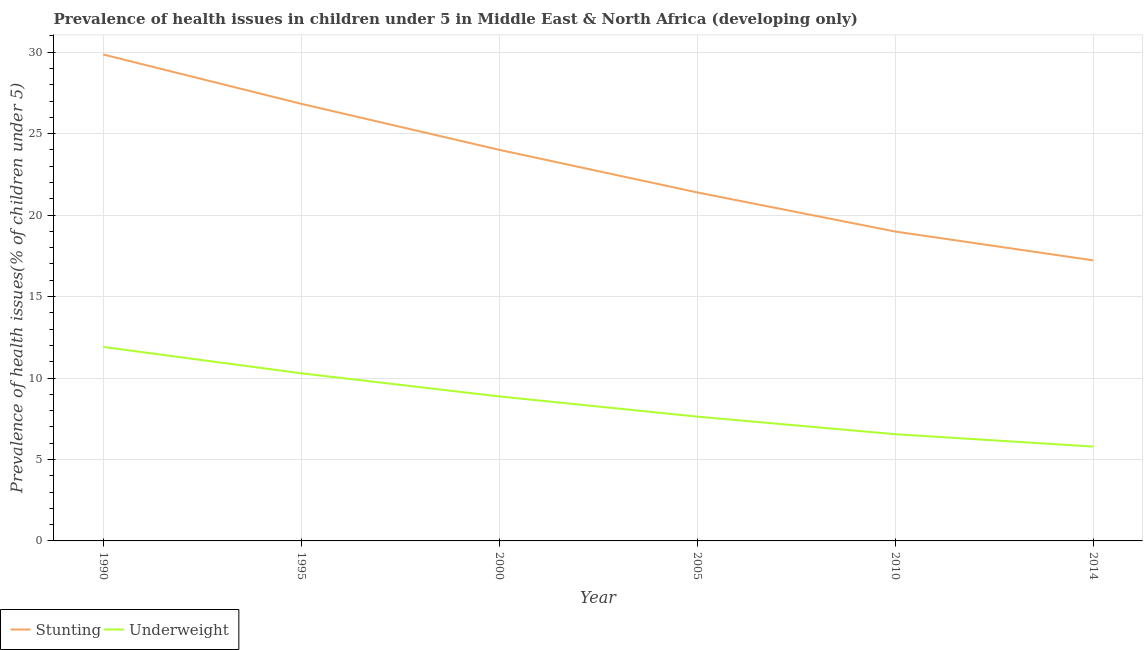How many different coloured lines are there?
Provide a short and direct response. 2. Does the line corresponding to percentage of stunted children intersect with the line corresponding to percentage of underweight children?
Your response must be concise. No. What is the percentage of underweight children in 2000?
Your answer should be compact. 8.87. Across all years, what is the maximum percentage of stunted children?
Offer a very short reply. 29.86. Across all years, what is the minimum percentage of underweight children?
Offer a terse response. 5.79. In which year was the percentage of underweight children minimum?
Keep it short and to the point. 2014. What is the total percentage of underweight children in the graph?
Provide a succinct answer. 51.04. What is the difference between the percentage of stunted children in 1990 and that in 2000?
Your answer should be compact. 5.85. What is the difference between the percentage of underweight children in 1990 and the percentage of stunted children in 2014?
Your answer should be very brief. -5.32. What is the average percentage of stunted children per year?
Your response must be concise. 23.05. In the year 2005, what is the difference between the percentage of underweight children and percentage of stunted children?
Offer a terse response. -13.76. What is the ratio of the percentage of underweight children in 1995 to that in 2000?
Your answer should be very brief. 1.16. What is the difference between the highest and the second highest percentage of underweight children?
Provide a succinct answer. 1.62. What is the difference between the highest and the lowest percentage of stunted children?
Your answer should be compact. 12.64. Is the percentage of stunted children strictly less than the percentage of underweight children over the years?
Make the answer very short. No. How many lines are there?
Ensure brevity in your answer.  2. How many years are there in the graph?
Provide a short and direct response. 6. Are the values on the major ticks of Y-axis written in scientific E-notation?
Your response must be concise. No. Does the graph contain any zero values?
Keep it short and to the point. No. How many legend labels are there?
Make the answer very short. 2. How are the legend labels stacked?
Offer a terse response. Horizontal. What is the title of the graph?
Provide a short and direct response. Prevalence of health issues in children under 5 in Middle East & North Africa (developing only). Does "Manufacturing industries and construction" appear as one of the legend labels in the graph?
Offer a very short reply. No. What is the label or title of the X-axis?
Make the answer very short. Year. What is the label or title of the Y-axis?
Make the answer very short. Prevalence of health issues(% of children under 5). What is the Prevalence of health issues(% of children under 5) in Stunting in 1990?
Your answer should be very brief. 29.86. What is the Prevalence of health issues(% of children under 5) in Underweight in 1990?
Keep it short and to the point. 11.91. What is the Prevalence of health issues(% of children under 5) in Stunting in 1995?
Ensure brevity in your answer.  26.83. What is the Prevalence of health issues(% of children under 5) in Underweight in 1995?
Keep it short and to the point. 10.29. What is the Prevalence of health issues(% of children under 5) in Stunting in 2000?
Keep it short and to the point. 24.01. What is the Prevalence of health issues(% of children under 5) in Underweight in 2000?
Your response must be concise. 8.87. What is the Prevalence of health issues(% of children under 5) of Stunting in 2005?
Offer a very short reply. 21.39. What is the Prevalence of health issues(% of children under 5) of Underweight in 2005?
Your response must be concise. 7.63. What is the Prevalence of health issues(% of children under 5) in Stunting in 2010?
Your answer should be very brief. 18.99. What is the Prevalence of health issues(% of children under 5) of Underweight in 2010?
Your answer should be compact. 6.55. What is the Prevalence of health issues(% of children under 5) of Stunting in 2014?
Provide a short and direct response. 17.23. What is the Prevalence of health issues(% of children under 5) of Underweight in 2014?
Ensure brevity in your answer.  5.79. Across all years, what is the maximum Prevalence of health issues(% of children under 5) in Stunting?
Your response must be concise. 29.86. Across all years, what is the maximum Prevalence of health issues(% of children under 5) in Underweight?
Your answer should be compact. 11.91. Across all years, what is the minimum Prevalence of health issues(% of children under 5) in Stunting?
Offer a terse response. 17.23. Across all years, what is the minimum Prevalence of health issues(% of children under 5) of Underweight?
Keep it short and to the point. 5.79. What is the total Prevalence of health issues(% of children under 5) of Stunting in the graph?
Your answer should be very brief. 138.32. What is the total Prevalence of health issues(% of children under 5) in Underweight in the graph?
Provide a succinct answer. 51.04. What is the difference between the Prevalence of health issues(% of children under 5) of Stunting in 1990 and that in 1995?
Make the answer very short. 3.03. What is the difference between the Prevalence of health issues(% of children under 5) of Underweight in 1990 and that in 1995?
Your answer should be compact. 1.62. What is the difference between the Prevalence of health issues(% of children under 5) in Stunting in 1990 and that in 2000?
Ensure brevity in your answer.  5.85. What is the difference between the Prevalence of health issues(% of children under 5) in Underweight in 1990 and that in 2000?
Your response must be concise. 3.04. What is the difference between the Prevalence of health issues(% of children under 5) of Stunting in 1990 and that in 2005?
Provide a succinct answer. 8.47. What is the difference between the Prevalence of health issues(% of children under 5) of Underweight in 1990 and that in 2005?
Provide a short and direct response. 4.28. What is the difference between the Prevalence of health issues(% of children under 5) in Stunting in 1990 and that in 2010?
Ensure brevity in your answer.  10.87. What is the difference between the Prevalence of health issues(% of children under 5) of Underweight in 1990 and that in 2010?
Your response must be concise. 5.36. What is the difference between the Prevalence of health issues(% of children under 5) of Stunting in 1990 and that in 2014?
Make the answer very short. 12.64. What is the difference between the Prevalence of health issues(% of children under 5) of Underweight in 1990 and that in 2014?
Give a very brief answer. 6.12. What is the difference between the Prevalence of health issues(% of children under 5) of Stunting in 1995 and that in 2000?
Your response must be concise. 2.83. What is the difference between the Prevalence of health issues(% of children under 5) in Underweight in 1995 and that in 2000?
Provide a short and direct response. 1.42. What is the difference between the Prevalence of health issues(% of children under 5) of Stunting in 1995 and that in 2005?
Your answer should be compact. 5.44. What is the difference between the Prevalence of health issues(% of children under 5) of Underweight in 1995 and that in 2005?
Keep it short and to the point. 2.66. What is the difference between the Prevalence of health issues(% of children under 5) in Stunting in 1995 and that in 2010?
Offer a terse response. 7.84. What is the difference between the Prevalence of health issues(% of children under 5) in Underweight in 1995 and that in 2010?
Offer a terse response. 3.74. What is the difference between the Prevalence of health issues(% of children under 5) of Stunting in 1995 and that in 2014?
Give a very brief answer. 9.61. What is the difference between the Prevalence of health issues(% of children under 5) in Underweight in 1995 and that in 2014?
Offer a very short reply. 4.5. What is the difference between the Prevalence of health issues(% of children under 5) in Stunting in 2000 and that in 2005?
Give a very brief answer. 2.61. What is the difference between the Prevalence of health issues(% of children under 5) of Underweight in 2000 and that in 2005?
Ensure brevity in your answer.  1.24. What is the difference between the Prevalence of health issues(% of children under 5) in Stunting in 2000 and that in 2010?
Provide a succinct answer. 5.02. What is the difference between the Prevalence of health issues(% of children under 5) in Underweight in 2000 and that in 2010?
Make the answer very short. 2.32. What is the difference between the Prevalence of health issues(% of children under 5) of Stunting in 2000 and that in 2014?
Provide a short and direct response. 6.78. What is the difference between the Prevalence of health issues(% of children under 5) of Underweight in 2000 and that in 2014?
Provide a short and direct response. 3.08. What is the difference between the Prevalence of health issues(% of children under 5) in Stunting in 2005 and that in 2010?
Provide a succinct answer. 2.4. What is the difference between the Prevalence of health issues(% of children under 5) in Underweight in 2005 and that in 2010?
Give a very brief answer. 1.08. What is the difference between the Prevalence of health issues(% of children under 5) of Stunting in 2005 and that in 2014?
Ensure brevity in your answer.  4.17. What is the difference between the Prevalence of health issues(% of children under 5) in Underweight in 2005 and that in 2014?
Give a very brief answer. 1.84. What is the difference between the Prevalence of health issues(% of children under 5) of Stunting in 2010 and that in 2014?
Offer a terse response. 1.77. What is the difference between the Prevalence of health issues(% of children under 5) of Underweight in 2010 and that in 2014?
Your answer should be very brief. 0.76. What is the difference between the Prevalence of health issues(% of children under 5) of Stunting in 1990 and the Prevalence of health issues(% of children under 5) of Underweight in 1995?
Make the answer very short. 19.57. What is the difference between the Prevalence of health issues(% of children under 5) of Stunting in 1990 and the Prevalence of health issues(% of children under 5) of Underweight in 2000?
Offer a terse response. 20.99. What is the difference between the Prevalence of health issues(% of children under 5) in Stunting in 1990 and the Prevalence of health issues(% of children under 5) in Underweight in 2005?
Make the answer very short. 22.23. What is the difference between the Prevalence of health issues(% of children under 5) in Stunting in 1990 and the Prevalence of health issues(% of children under 5) in Underweight in 2010?
Provide a short and direct response. 23.31. What is the difference between the Prevalence of health issues(% of children under 5) of Stunting in 1990 and the Prevalence of health issues(% of children under 5) of Underweight in 2014?
Your response must be concise. 24.07. What is the difference between the Prevalence of health issues(% of children under 5) of Stunting in 1995 and the Prevalence of health issues(% of children under 5) of Underweight in 2000?
Ensure brevity in your answer.  17.96. What is the difference between the Prevalence of health issues(% of children under 5) of Stunting in 1995 and the Prevalence of health issues(% of children under 5) of Underweight in 2005?
Offer a terse response. 19.2. What is the difference between the Prevalence of health issues(% of children under 5) of Stunting in 1995 and the Prevalence of health issues(% of children under 5) of Underweight in 2010?
Provide a succinct answer. 20.28. What is the difference between the Prevalence of health issues(% of children under 5) of Stunting in 1995 and the Prevalence of health issues(% of children under 5) of Underweight in 2014?
Ensure brevity in your answer.  21.04. What is the difference between the Prevalence of health issues(% of children under 5) of Stunting in 2000 and the Prevalence of health issues(% of children under 5) of Underweight in 2005?
Keep it short and to the point. 16.38. What is the difference between the Prevalence of health issues(% of children under 5) in Stunting in 2000 and the Prevalence of health issues(% of children under 5) in Underweight in 2010?
Give a very brief answer. 17.46. What is the difference between the Prevalence of health issues(% of children under 5) in Stunting in 2000 and the Prevalence of health issues(% of children under 5) in Underweight in 2014?
Make the answer very short. 18.22. What is the difference between the Prevalence of health issues(% of children under 5) of Stunting in 2005 and the Prevalence of health issues(% of children under 5) of Underweight in 2010?
Your answer should be very brief. 14.84. What is the difference between the Prevalence of health issues(% of children under 5) in Stunting in 2005 and the Prevalence of health issues(% of children under 5) in Underweight in 2014?
Give a very brief answer. 15.6. What is the difference between the Prevalence of health issues(% of children under 5) of Stunting in 2010 and the Prevalence of health issues(% of children under 5) of Underweight in 2014?
Give a very brief answer. 13.2. What is the average Prevalence of health issues(% of children under 5) in Stunting per year?
Offer a very short reply. 23.05. What is the average Prevalence of health issues(% of children under 5) in Underweight per year?
Your response must be concise. 8.51. In the year 1990, what is the difference between the Prevalence of health issues(% of children under 5) in Stunting and Prevalence of health issues(% of children under 5) in Underweight?
Offer a very short reply. 17.95. In the year 1995, what is the difference between the Prevalence of health issues(% of children under 5) of Stunting and Prevalence of health issues(% of children under 5) of Underweight?
Your answer should be very brief. 16.54. In the year 2000, what is the difference between the Prevalence of health issues(% of children under 5) of Stunting and Prevalence of health issues(% of children under 5) of Underweight?
Ensure brevity in your answer.  15.14. In the year 2005, what is the difference between the Prevalence of health issues(% of children under 5) of Stunting and Prevalence of health issues(% of children under 5) of Underweight?
Your answer should be very brief. 13.76. In the year 2010, what is the difference between the Prevalence of health issues(% of children under 5) of Stunting and Prevalence of health issues(% of children under 5) of Underweight?
Your answer should be compact. 12.44. In the year 2014, what is the difference between the Prevalence of health issues(% of children under 5) of Stunting and Prevalence of health issues(% of children under 5) of Underweight?
Offer a terse response. 11.43. What is the ratio of the Prevalence of health issues(% of children under 5) in Stunting in 1990 to that in 1995?
Keep it short and to the point. 1.11. What is the ratio of the Prevalence of health issues(% of children under 5) of Underweight in 1990 to that in 1995?
Make the answer very short. 1.16. What is the ratio of the Prevalence of health issues(% of children under 5) in Stunting in 1990 to that in 2000?
Offer a very short reply. 1.24. What is the ratio of the Prevalence of health issues(% of children under 5) of Underweight in 1990 to that in 2000?
Your answer should be very brief. 1.34. What is the ratio of the Prevalence of health issues(% of children under 5) of Stunting in 1990 to that in 2005?
Keep it short and to the point. 1.4. What is the ratio of the Prevalence of health issues(% of children under 5) in Underweight in 1990 to that in 2005?
Offer a very short reply. 1.56. What is the ratio of the Prevalence of health issues(% of children under 5) of Stunting in 1990 to that in 2010?
Provide a short and direct response. 1.57. What is the ratio of the Prevalence of health issues(% of children under 5) in Underweight in 1990 to that in 2010?
Give a very brief answer. 1.82. What is the ratio of the Prevalence of health issues(% of children under 5) in Stunting in 1990 to that in 2014?
Offer a terse response. 1.73. What is the ratio of the Prevalence of health issues(% of children under 5) of Underweight in 1990 to that in 2014?
Offer a very short reply. 2.06. What is the ratio of the Prevalence of health issues(% of children under 5) of Stunting in 1995 to that in 2000?
Your response must be concise. 1.12. What is the ratio of the Prevalence of health issues(% of children under 5) in Underweight in 1995 to that in 2000?
Give a very brief answer. 1.16. What is the ratio of the Prevalence of health issues(% of children under 5) in Stunting in 1995 to that in 2005?
Keep it short and to the point. 1.25. What is the ratio of the Prevalence of health issues(% of children under 5) of Underweight in 1995 to that in 2005?
Provide a succinct answer. 1.35. What is the ratio of the Prevalence of health issues(% of children under 5) in Stunting in 1995 to that in 2010?
Provide a succinct answer. 1.41. What is the ratio of the Prevalence of health issues(% of children under 5) of Underweight in 1995 to that in 2010?
Provide a short and direct response. 1.57. What is the ratio of the Prevalence of health issues(% of children under 5) of Stunting in 1995 to that in 2014?
Keep it short and to the point. 1.56. What is the ratio of the Prevalence of health issues(% of children under 5) of Underweight in 1995 to that in 2014?
Provide a succinct answer. 1.78. What is the ratio of the Prevalence of health issues(% of children under 5) in Stunting in 2000 to that in 2005?
Keep it short and to the point. 1.12. What is the ratio of the Prevalence of health issues(% of children under 5) of Underweight in 2000 to that in 2005?
Your answer should be very brief. 1.16. What is the ratio of the Prevalence of health issues(% of children under 5) of Stunting in 2000 to that in 2010?
Keep it short and to the point. 1.26. What is the ratio of the Prevalence of health issues(% of children under 5) in Underweight in 2000 to that in 2010?
Your response must be concise. 1.35. What is the ratio of the Prevalence of health issues(% of children under 5) of Stunting in 2000 to that in 2014?
Give a very brief answer. 1.39. What is the ratio of the Prevalence of health issues(% of children under 5) in Underweight in 2000 to that in 2014?
Your answer should be compact. 1.53. What is the ratio of the Prevalence of health issues(% of children under 5) of Stunting in 2005 to that in 2010?
Provide a short and direct response. 1.13. What is the ratio of the Prevalence of health issues(% of children under 5) of Underweight in 2005 to that in 2010?
Ensure brevity in your answer.  1.16. What is the ratio of the Prevalence of health issues(% of children under 5) in Stunting in 2005 to that in 2014?
Provide a short and direct response. 1.24. What is the ratio of the Prevalence of health issues(% of children under 5) in Underweight in 2005 to that in 2014?
Your response must be concise. 1.32. What is the ratio of the Prevalence of health issues(% of children under 5) in Stunting in 2010 to that in 2014?
Make the answer very short. 1.1. What is the ratio of the Prevalence of health issues(% of children under 5) of Underweight in 2010 to that in 2014?
Ensure brevity in your answer.  1.13. What is the difference between the highest and the second highest Prevalence of health issues(% of children under 5) in Stunting?
Ensure brevity in your answer.  3.03. What is the difference between the highest and the second highest Prevalence of health issues(% of children under 5) in Underweight?
Provide a succinct answer. 1.62. What is the difference between the highest and the lowest Prevalence of health issues(% of children under 5) of Stunting?
Your answer should be compact. 12.64. What is the difference between the highest and the lowest Prevalence of health issues(% of children under 5) of Underweight?
Offer a terse response. 6.12. 